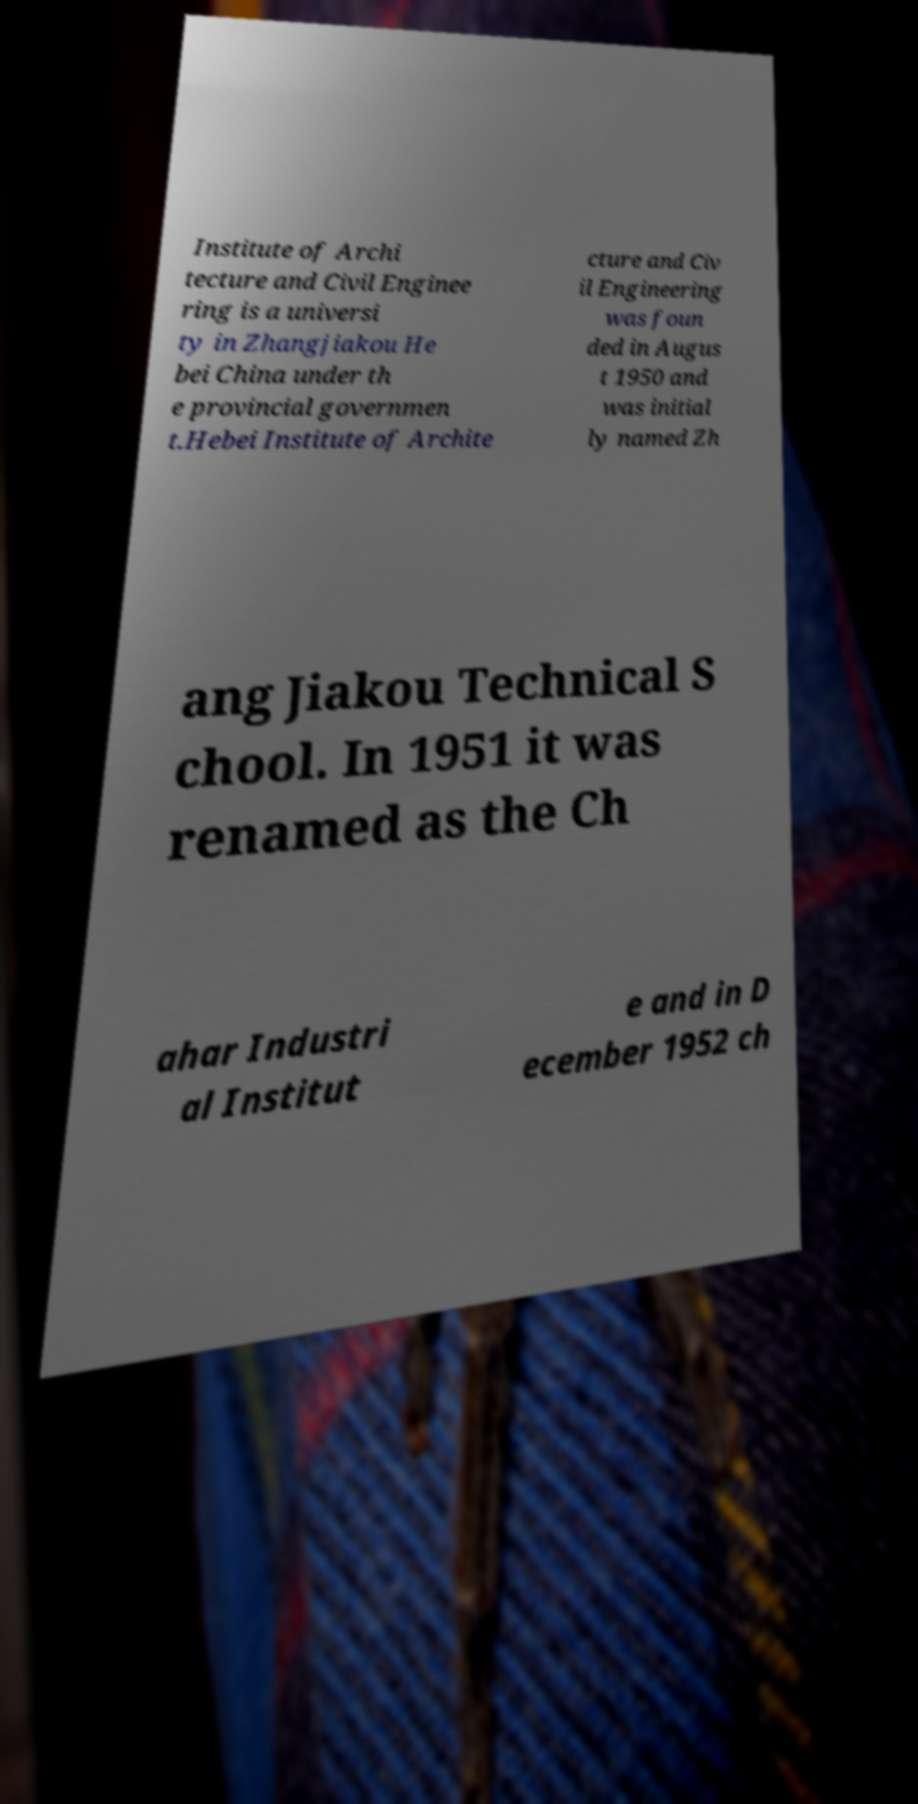Could you extract and type out the text from this image? Institute of Archi tecture and Civil Enginee ring is a universi ty in Zhangjiakou He bei China under th e provincial governmen t.Hebei Institute of Archite cture and Civ il Engineering was foun ded in Augus t 1950 and was initial ly named Zh ang Jiakou Technical S chool. In 1951 it was renamed as the Ch ahar Industri al Institut e and in D ecember 1952 ch 